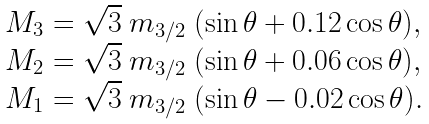<formula> <loc_0><loc_0><loc_500><loc_500>\begin{array} { l } M _ { 3 } = \sqrt { 3 } \ m _ { 3 / 2 } \ ( \sin \theta + 0 . 1 2 \cos \theta ) , \\ M _ { 2 } = \sqrt { 3 } \ m _ { 3 / 2 } \ ( \sin \theta + 0 . 0 6 \cos \theta ) , \\ M _ { 1 } = \sqrt { 3 } \ m _ { 3 / 2 } \ ( \sin \theta - 0 . 0 2 \cos \theta ) . \end{array}</formula> 